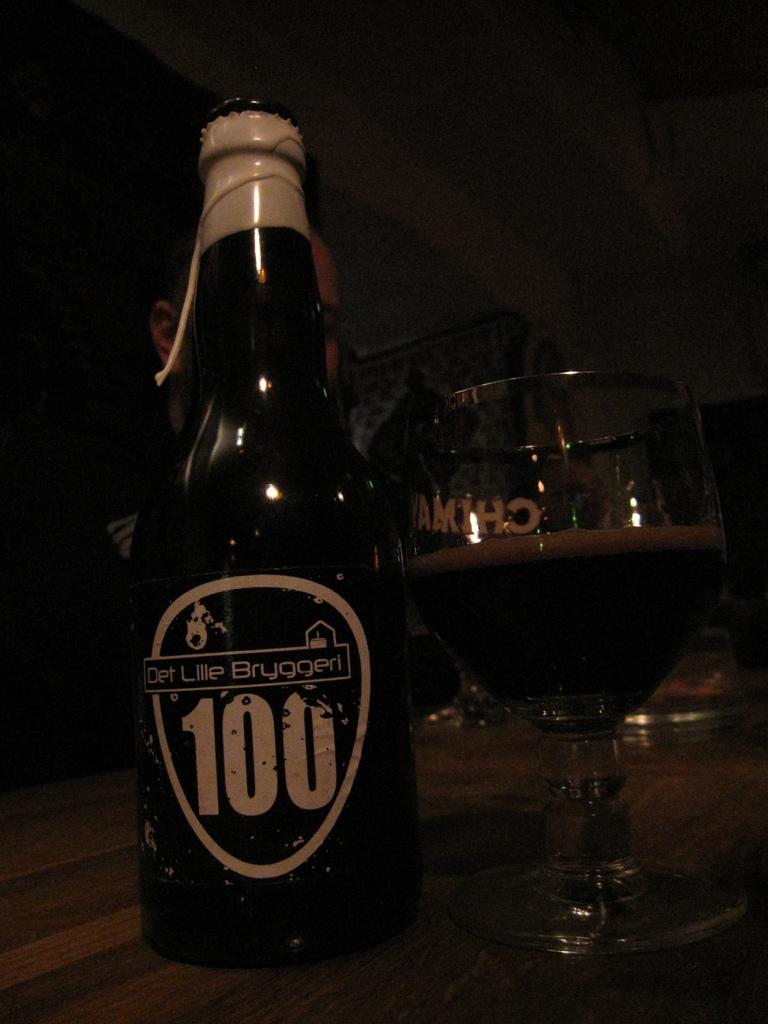<image>
Give a short and clear explanation of the subsequent image. AN AMBER BOTTLE OF DET LILLE BRUGGERI BEER AND GLASS 